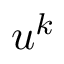Convert formula to latex. <formula><loc_0><loc_0><loc_500><loc_500>u ^ { k }</formula> 